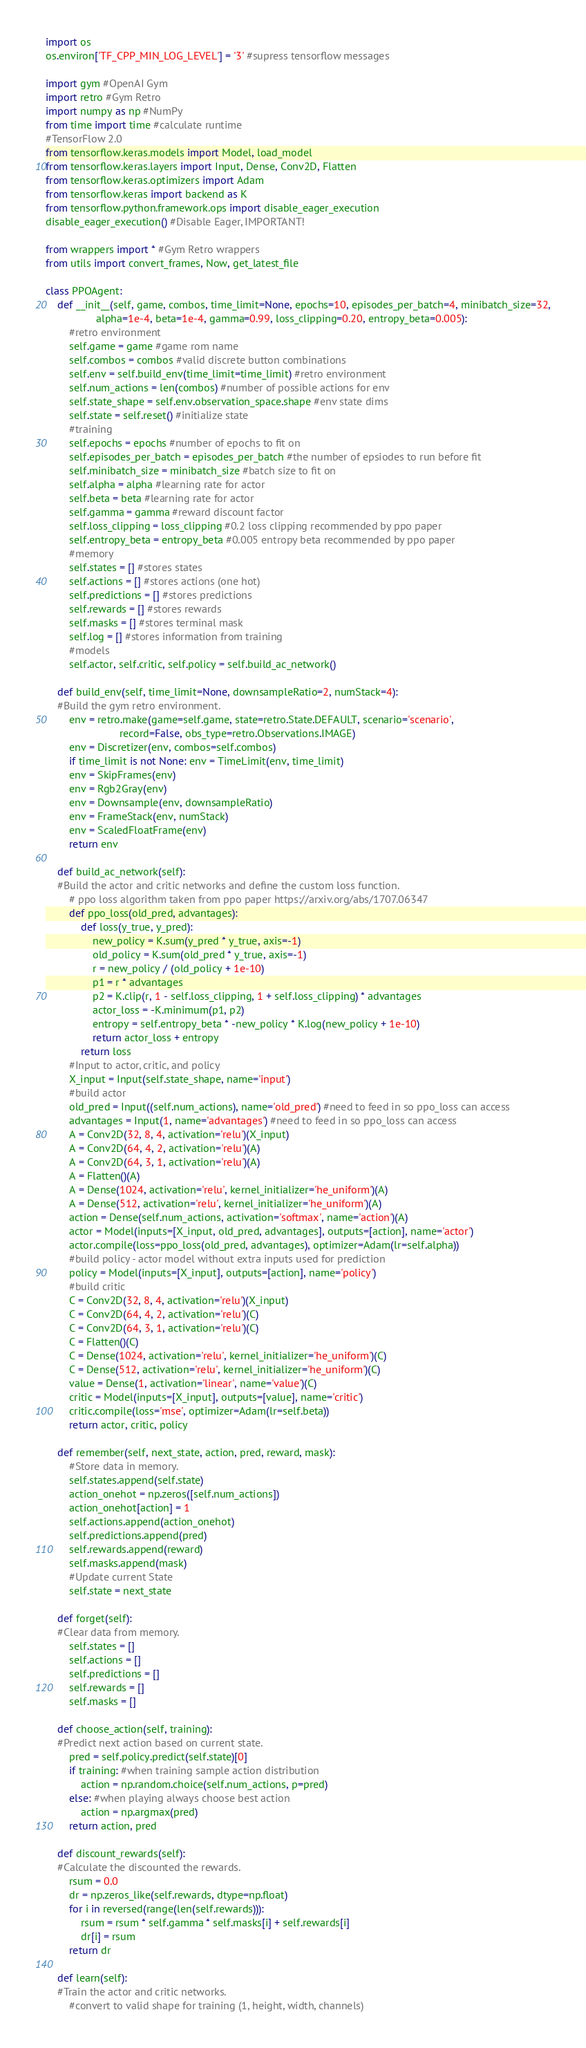<code> <loc_0><loc_0><loc_500><loc_500><_Python_>import os
os.environ['TF_CPP_MIN_LOG_LEVEL'] = '3' #supress tensorflow messages

import gym #OpenAI Gym
import retro #Gym Retro
import numpy as np #NumPy
from time import time #calculate runtime
#TensorFlow 2.0
from tensorflow.keras.models import Model, load_model
from tensorflow.keras.layers import Input, Dense, Conv2D, Flatten
from tensorflow.keras.optimizers import Adam
from tensorflow.keras import backend as K
from tensorflow.python.framework.ops import disable_eager_execution
disable_eager_execution() #Disable Eager, IMPORTANT!

from wrappers import * #Gym Retro wrappers
from utils import convert_frames, Now, get_latest_file

class PPOAgent:
    def __init__(self, game, combos, time_limit=None, epochs=10, episodes_per_batch=4, minibatch_size=32,
                 alpha=1e-4, beta=1e-4, gamma=0.99, loss_clipping=0.20, entropy_beta=0.005):
        #retro environment
        self.game = game #game rom name
        self.combos = combos #valid discrete button combinations
        self.env = self.build_env(time_limit=time_limit) #retro environment
        self.num_actions = len(combos) #number of possible actions for env
        self.state_shape = self.env.observation_space.shape #env state dims
        self.state = self.reset() #initialize state
        #training
        self.epochs = epochs #number of epochs to fit on
        self.episodes_per_batch = episodes_per_batch #the number of epsiodes to run before fit
        self.minibatch_size = minibatch_size #batch size to fit on
        self.alpha = alpha #learning rate for actor
        self.beta = beta #learning rate for actor
        self.gamma = gamma #reward discount factor
        self.loss_clipping = loss_clipping #0.2 loss clipping recommended by ppo paper
        self.entropy_beta = entropy_beta #0.005 entropy beta recommended by ppo paper
        #memory
        self.states = [] #stores states
        self.actions = [] #stores actions (one hot)
        self.predictions = [] #stores predictions
        self.rewards = [] #stores rewards
        self.masks = [] #stores terminal mask
        self.log = [] #stores information from training
        #models
        self.actor, self.critic, self.policy = self.build_ac_network()

    def build_env(self, time_limit=None, downsampleRatio=2, numStack=4):
    #Build the gym retro environment.
        env = retro.make(game=self.game, state=retro.State.DEFAULT, scenario='scenario',
                         record=False, obs_type=retro.Observations.IMAGE)
        env = Discretizer(env, combos=self.combos)
        if time_limit is not None: env = TimeLimit(env, time_limit)
        env = SkipFrames(env)
        env = Rgb2Gray(env)
        env = Downsample(env, downsampleRatio)
        env = FrameStack(env, numStack)
        env = ScaledFloatFrame(env)
        return env
        
    def build_ac_network(self):
    #Build the actor and critic networks and define the custom loss function.
        # ppo loss algorithm taken from ppo paper https://arxiv.org/abs/1707.06347
        def ppo_loss(old_pred, advantages):
            def loss(y_true, y_pred):
                new_policy = K.sum(y_pred * y_true, axis=-1)
                old_policy = K.sum(old_pred * y_true, axis=-1)
                r = new_policy / (old_policy + 1e-10)
                p1 = r * advantages
                p2 = K.clip(r, 1 - self.loss_clipping, 1 + self.loss_clipping) * advantages
                actor_loss = -K.minimum(p1, p2)
                entropy = self.entropy_beta * -new_policy * K.log(new_policy + 1e-10)
                return actor_loss + entropy
            return loss
        #Input to actor, critic, and policy
        X_input = Input(self.state_shape, name='input')
        #build actor
        old_pred = Input((self.num_actions), name='old_pred') #need to feed in so ppo_loss can access
        advantages = Input(1, name='advantages') #need to feed in so ppo_loss can access
        A = Conv2D(32, 8, 4, activation='relu')(X_input)
        A = Conv2D(64, 4, 2, activation='relu')(A)
        A = Conv2D(64, 3, 1, activation='relu')(A)
        A = Flatten()(A)
        A = Dense(1024, activation='relu', kernel_initializer='he_uniform')(A)
        A = Dense(512, activation='relu', kernel_initializer='he_uniform')(A)
        action = Dense(self.num_actions, activation='softmax', name='action')(A)
        actor = Model(inputs=[X_input, old_pred, advantages], outputs=[action], name='actor')
        actor.compile(loss=ppo_loss(old_pred, advantages), optimizer=Adam(lr=self.alpha))
        #build policy - actor model without extra inputs used for prediction
        policy = Model(inputs=[X_input], outputs=[action], name='policy') 
        #build critic
        C = Conv2D(32, 8, 4, activation='relu')(X_input)
        C = Conv2D(64, 4, 2, activation='relu')(C)
        C = Conv2D(64, 3, 1, activation='relu')(C)
        C = Flatten()(C)
        C = Dense(1024, activation='relu', kernel_initializer='he_uniform')(C)
        C = Dense(512, activation='relu', kernel_initializer='he_uniform')(C)
        value = Dense(1, activation='linear', name='value')(C)
        critic = Model(inputs=[X_input], outputs=[value], name='critic')
        critic.compile(loss='mse', optimizer=Adam(lr=self.beta))
        return actor, critic, policy

    def remember(self, next_state, action, pred, reward, mask):
        #Store data in memory.
        self.states.append(self.state)
        action_onehot = np.zeros([self.num_actions])
        action_onehot[action] = 1
        self.actions.append(action_onehot)
        self.predictions.append(pred)
        self.rewards.append(reward)
        self.masks.append(mask)
        #Update current State
        self.state = next_state
        
    def forget(self):
    #Clear data from memory.
        self.states = []
        self.actions = []
        self.predictions = []
        self.rewards = []
        self.masks = []

    def choose_action(self, training):
    #Predict next action based on current state.
        pred = self.policy.predict(self.state)[0]
        if training: #when training sample action distribution
            action = np.random.choice(self.num_actions, p=pred)
        else: #when playing always choose best action
            action = np.argmax(pred)
        return action, pred

    def discount_rewards(self):
    #Calculate the discounted the rewards.
        rsum = 0.0
        dr = np.zeros_like(self.rewards, dtype=np.float)
        for i in reversed(range(len(self.rewards))):
            rsum = rsum * self.gamma * self.masks[i] + self.rewards[i]
            dr[i] = rsum
        return dr
                
    def learn(self):
    #Train the actor and critic networks.
        #convert to valid shape for training (1, height, width, channels)</code> 